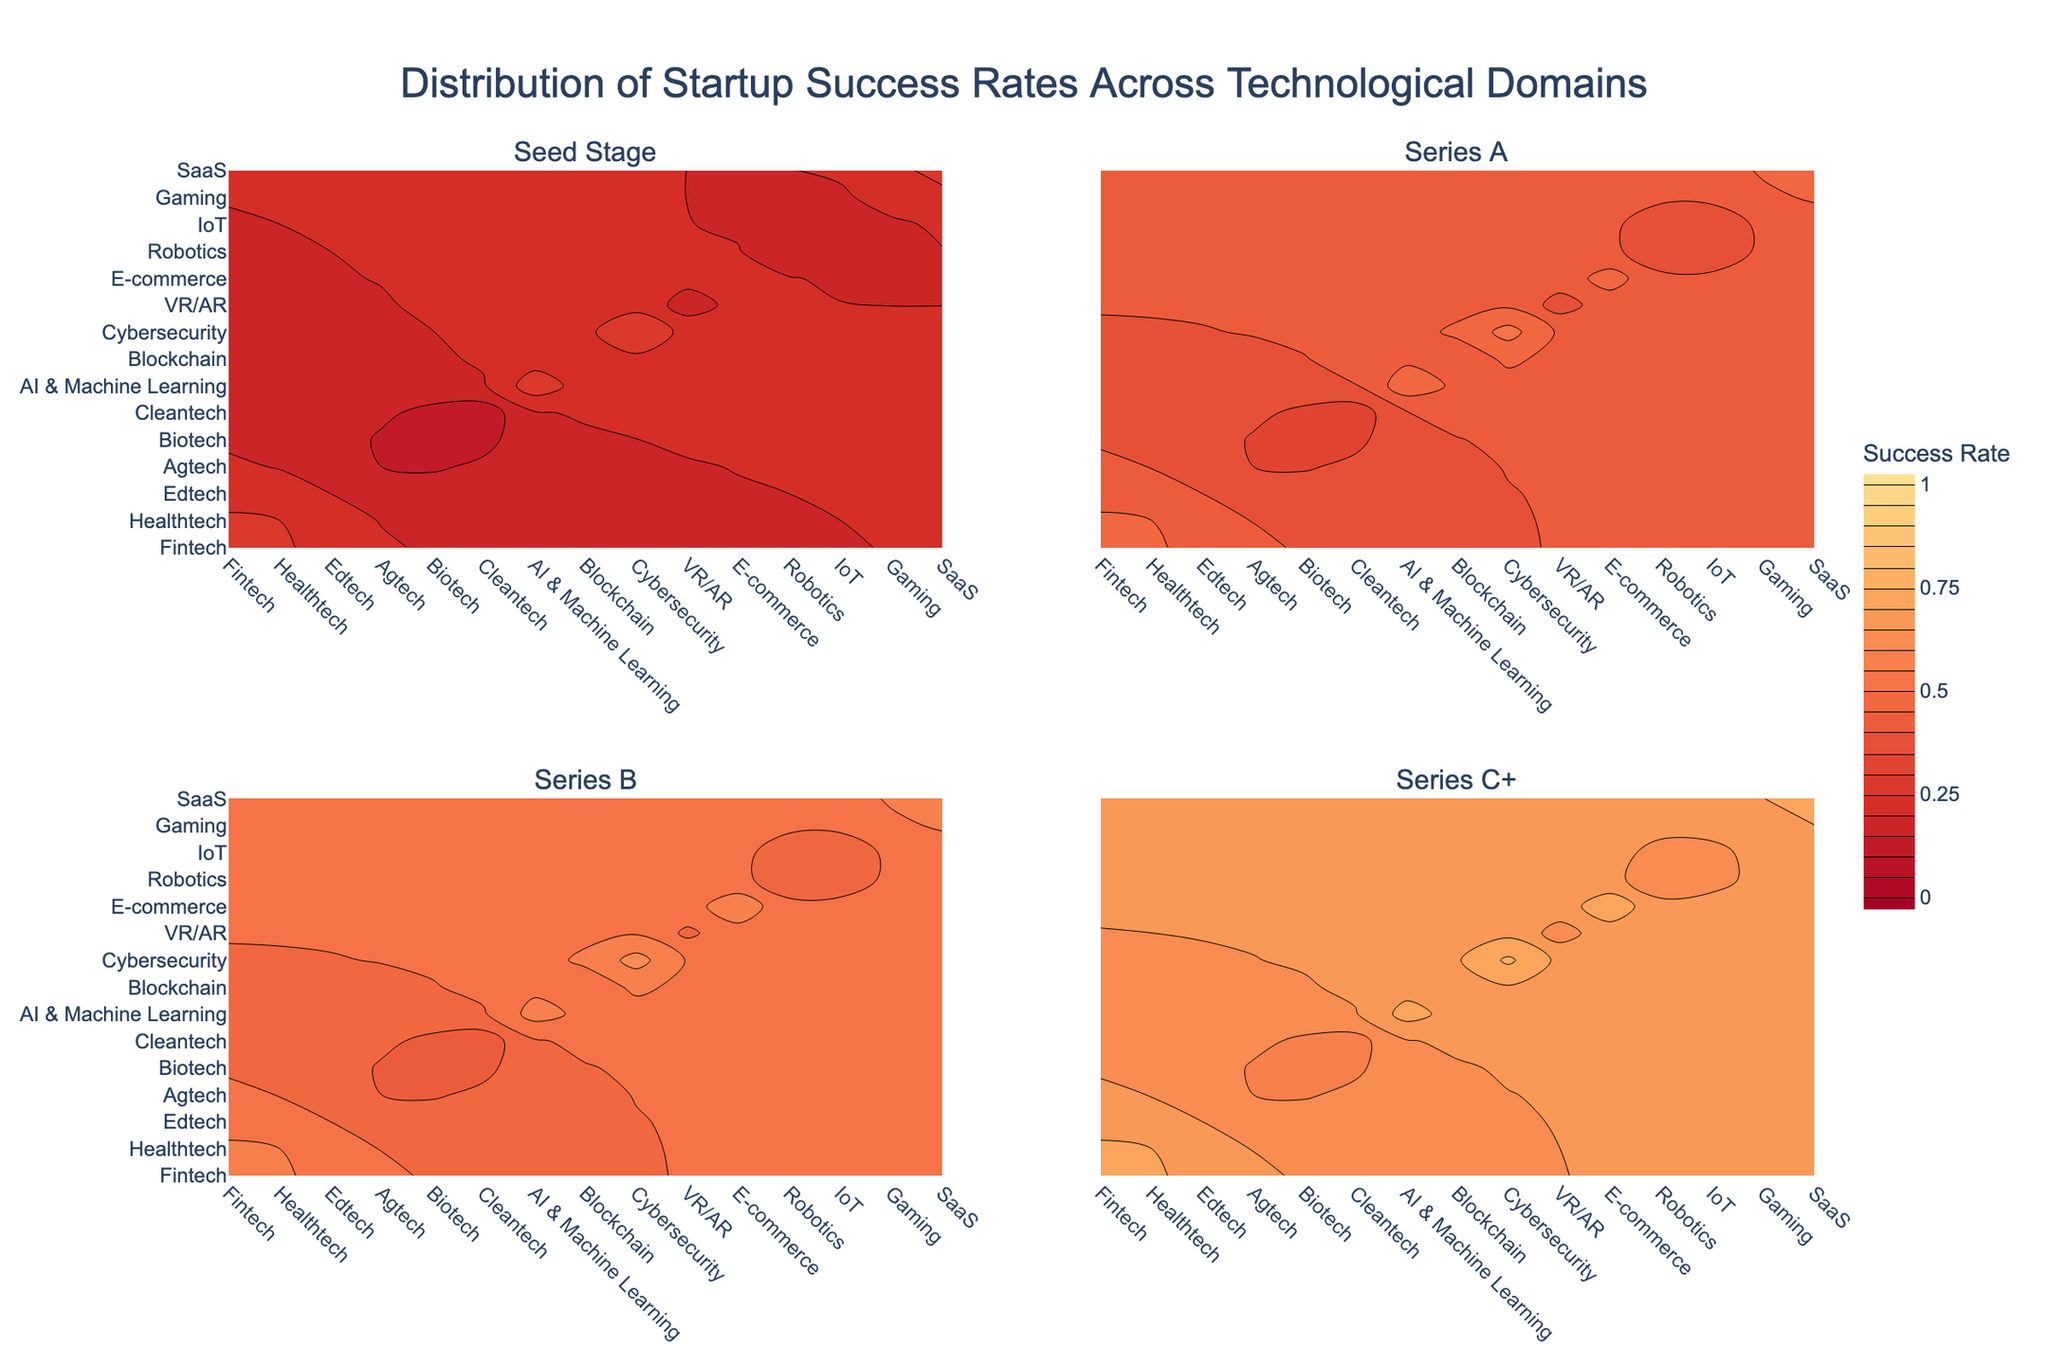what is the title of the figure? The title is located at the top center of the figure and is usually in a larger font size compared to other text elements
Answer: Distribution of Startup Success Rates Across Technological Domains Which technological domain shows the highest success rate at the Seed Stage? Look at the Seed Stage subplot and check which domain has the highest contour values
Answer: Fintech What is the approximate success rate range for the Series C+ stage in the VR/AR domain? Find the contour plot for Series C+ and locate the VR/AR domain on the x-axis; then identify the range of the contours
Answer: 0.6–0.65 Which stage has the least variation in success rates across domains? Compare the range of success rates (difference between maximum and minimum contour values) in each stage subplot
Answer: Series A Which domain consistently shows a high success rate across all stages? Observe all subplots (Seed Stage, Series A, Series B, Series C+) and identify the domain with consistently high contour values
Answer: Cybersecurity How do success rates in the Cleantech domain compare between the Seed Stage and Series C+ stage? Check the contour values for Cleantech in both the Seed Stage and Series C+ subplots
Answer: Success rate at the Seed Stage is lower than Series C+ What is the general trend in success rates from Seed Stage to Series C+ across all domains? Observe the contour values across all subplots in a sequential manner from Seed Stage to Series C+
Answer: Success rates generally increase from Seed Stage to Series C+ Which domains have similar success rates at the Series B stage? Identify contour values at the Series B stage for different domains and find those with close values
Answer: Examples include Edtech and Cleantech 